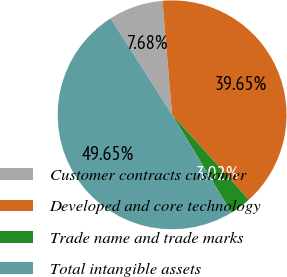Convert chart. <chart><loc_0><loc_0><loc_500><loc_500><pie_chart><fcel>Customer contracts customer<fcel>Developed and core technology<fcel>Trade name and trade marks<fcel>Total intangible assets<nl><fcel>7.68%<fcel>39.65%<fcel>3.02%<fcel>49.65%<nl></chart> 